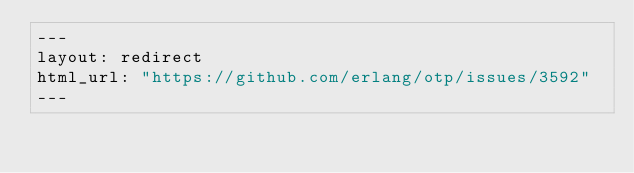<code> <loc_0><loc_0><loc_500><loc_500><_HTML_>---
layout: redirect
html_url: "https://github.com/erlang/otp/issues/3592"
---</code> 